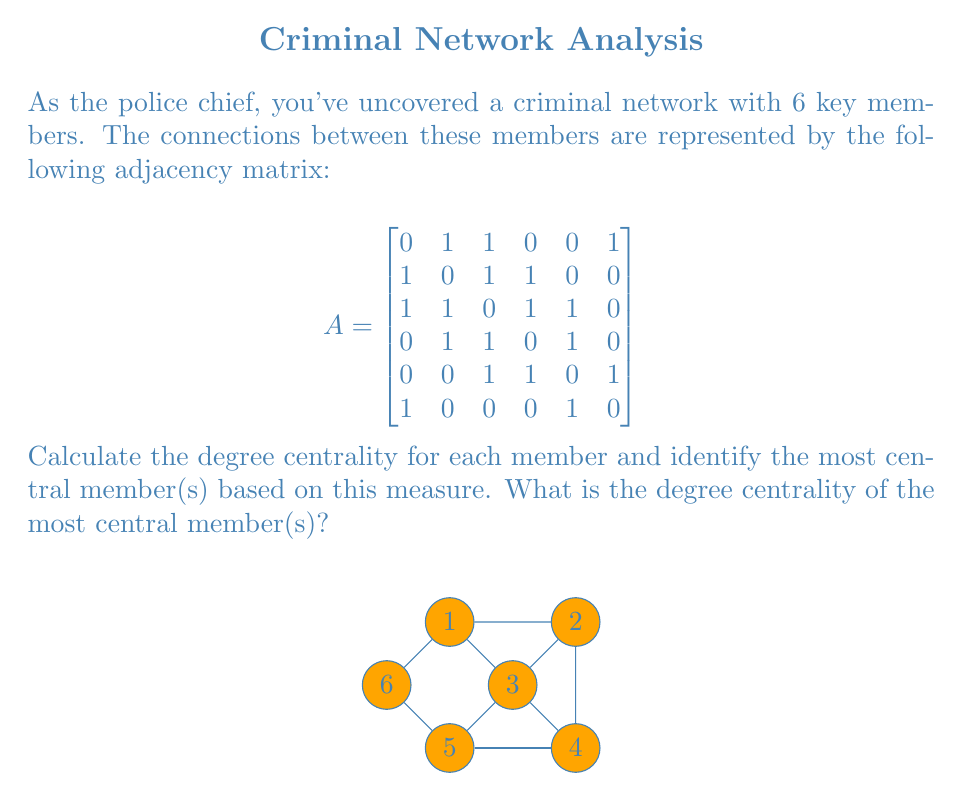Show me your answer to this math problem. To solve this problem, we'll follow these steps:

1) First, recall that degree centrality is defined as the number of direct connections a node has. In an undirected graph, it's calculated as:

   $$C_D(v) = \frac{deg(v)}{n-1}$$

   where $deg(v)$ is the degree of vertex $v$, and $n$ is the total number of nodes.

2) From the adjacency matrix, we can calculate the degree of each node by summing its row (or column, as the matrix is symmetric):

   Node 1: 3 connections
   Node 2: 3 connections
   Node 3: 4 connections
   Node 4: 3 connections
   Node 5: 3 connections
   Node 6: 2 connections

3) Now, we can calculate the degree centrality for each node:

   $$C_D(1) = C_D(2) = C_D(4) = C_D(5) = \frac{3}{5} = 0.6$$
   $$C_D(3) = \frac{4}{5} = 0.8$$
   $$C_D(6) = \frac{2}{5} = 0.4$$

4) The highest degree centrality is 0.8, corresponding to Node 3.

Therefore, Node 3 is the most central member based on degree centrality, with a centrality measure of 0.8.
Answer: 0.8 